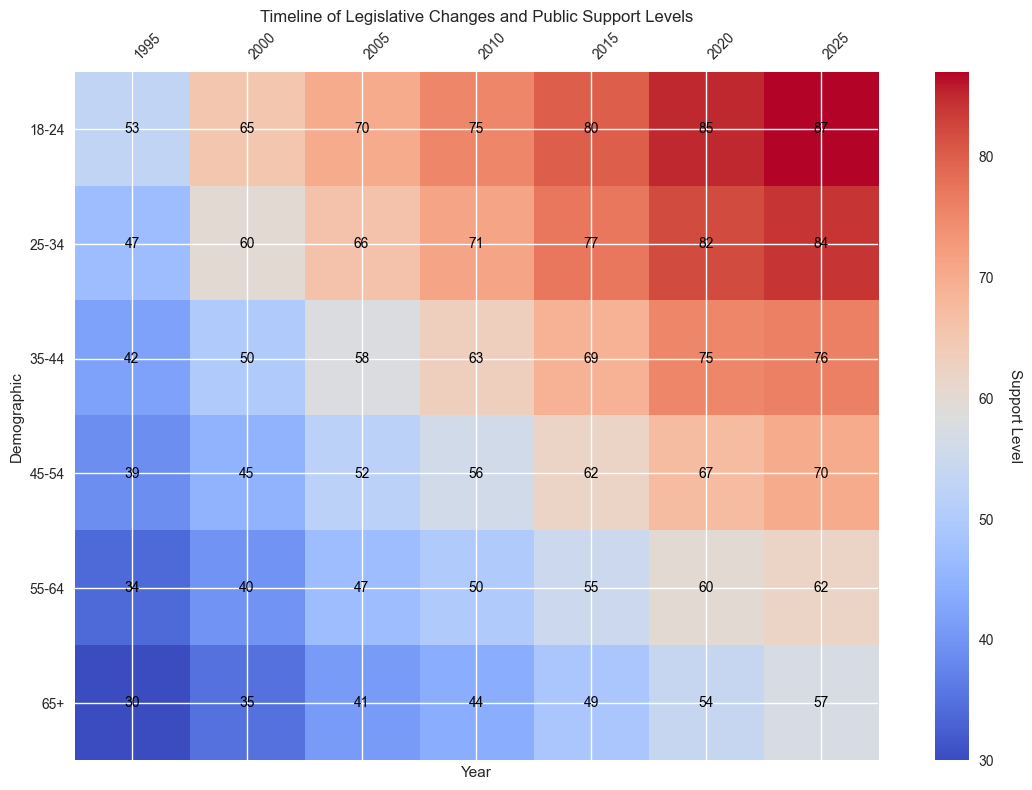What legislative change had the highest support level among the 18-24 demographic? To find the answer, locate the row corresponding to the 18-24 demographic across different years. Observe the values in this row, and note that the highest value is 87 in 2025 for Change G.
Answer: Change G Which year had the lowest support level among the 65+ demographic? Identify the values in the row corresponding to the 65+ demographic across different years. The lowest value in this row is 30 in 1995 for Change A.
Answer: 1995 How did the support level for the 35-44 demographic change from 2005 to 2010? Find the values for the 35-44 demographic in the years 2005 and 2010. The support levels are 58 in 2005 and 63 in 2010. The change is 63 - 58 = 5.
Answer: Increased by 5 Which demographic showed the most significant increase in support level between 2000 and 2005? Look at the differences in support levels between 2000 and 2005 for each demographic. Calculate the increases: 18-24 (70-65=5), 25-34 (66-60=6), 35-44 (58-50=8), 45-54 (52-45=7), 55-64 (47-40=7), 65+ (41-35=6). The 35-44 demographic had the most significant increase of 8.
Answer: 35-44 What was the average support level for Change E across all demographics? Identify the support levels for each demographic for Change E in the year 2015. The values are 80, 77, 69, 62, 55, and 49. Sum these values: 80 + 77 + 69 + 62 + 55 + 49 = 392. Divide by the number of demographics (6): 392 / 6 = 65.33.
Answer: 65.33 By looking at the color gradient, which demographic consistently shows lower support levels compared to others? Visually examine the overall color distribution in the rows of the heatmap. The 65+ demographic consistently displays cooler (darker) colors indicating lower support levels.
Answer: 65+ How did the support level for the 25-34 demographic evolve from 1995 to 2025? Look at the values for the 25-34 demographic across the years: 1995 (47), 2000 (60), 2005 (66), 2010 (71), 2015 (77), 2020 (82), 2025 (84). Summarize the trend as increasing over time.
Answer: Increased over time What is the difference in the support level between the 18-24 and 65+ demographics in 2020? Find the support levels for both demographics in 2020: 18-24 (85), 65+ (54). Subtract the values: 85 - 54 = 31.
Answer: 31 Which demographic had the highest support level in 2015, and what was it? Identify the highest value among all demographics in 2015. The highest support level is 80 for the 18-24 demographic.
Answer: 18-24, 80 